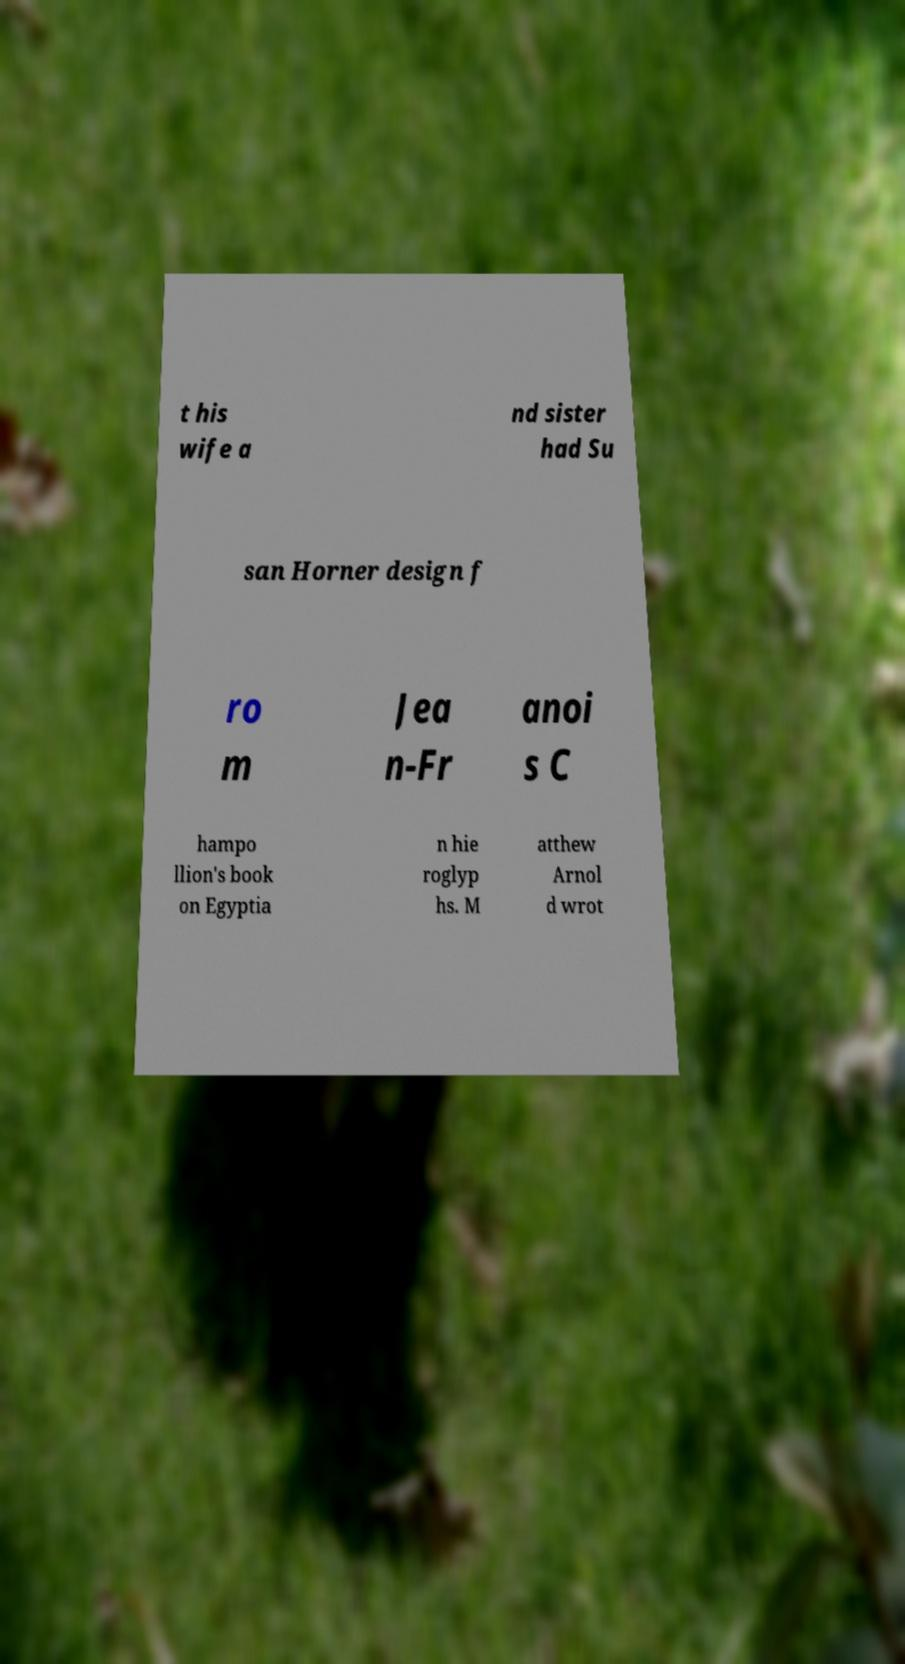Can you accurately transcribe the text from the provided image for me? t his wife a nd sister had Su san Horner design f ro m Jea n-Fr anoi s C hampo llion's book on Egyptia n hie roglyp hs. M atthew Arnol d wrot 